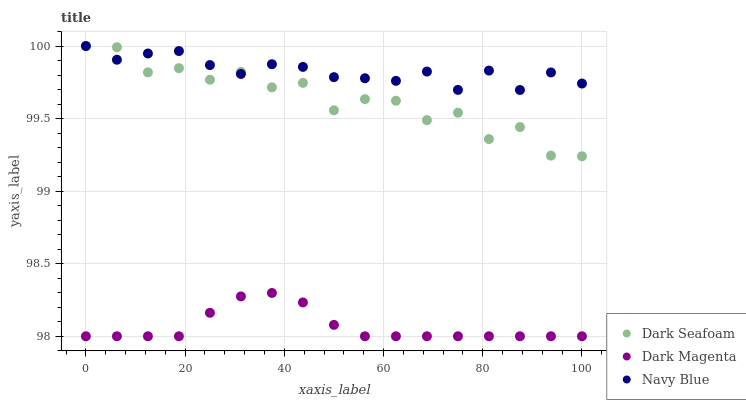Does Dark Magenta have the minimum area under the curve?
Answer yes or no. Yes. Does Navy Blue have the maximum area under the curve?
Answer yes or no. Yes. Does Dark Seafoam have the minimum area under the curve?
Answer yes or no. No. Does Dark Seafoam have the maximum area under the curve?
Answer yes or no. No. Is Dark Magenta the smoothest?
Answer yes or no. Yes. Is Dark Seafoam the roughest?
Answer yes or no. Yes. Is Dark Seafoam the smoothest?
Answer yes or no. No. Is Dark Magenta the roughest?
Answer yes or no. No. Does Dark Magenta have the lowest value?
Answer yes or no. Yes. Does Dark Seafoam have the lowest value?
Answer yes or no. No. Does Dark Seafoam have the highest value?
Answer yes or no. Yes. Does Dark Magenta have the highest value?
Answer yes or no. No. Is Dark Magenta less than Dark Seafoam?
Answer yes or no. Yes. Is Dark Seafoam greater than Dark Magenta?
Answer yes or no. Yes. Does Dark Seafoam intersect Navy Blue?
Answer yes or no. Yes. Is Dark Seafoam less than Navy Blue?
Answer yes or no. No. Is Dark Seafoam greater than Navy Blue?
Answer yes or no. No. Does Dark Magenta intersect Dark Seafoam?
Answer yes or no. No. 